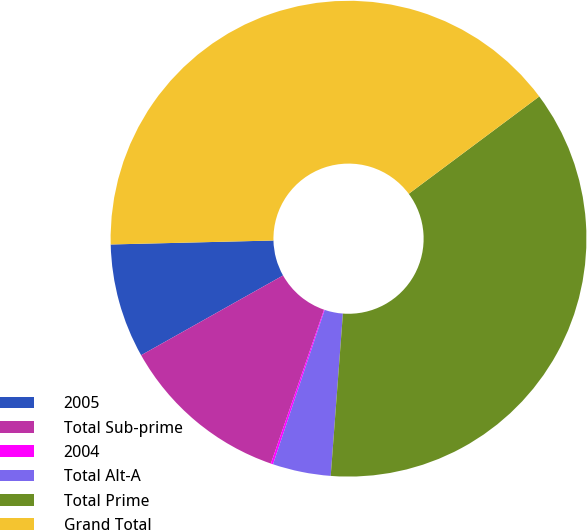Convert chart. <chart><loc_0><loc_0><loc_500><loc_500><pie_chart><fcel>2005<fcel>Total Sub-prime<fcel>2004<fcel>Total Alt-A<fcel>Total Prime<fcel>Grand Total<nl><fcel>7.76%<fcel>11.56%<fcel>0.15%<fcel>3.95%<fcel>36.39%<fcel>40.19%<nl></chart> 